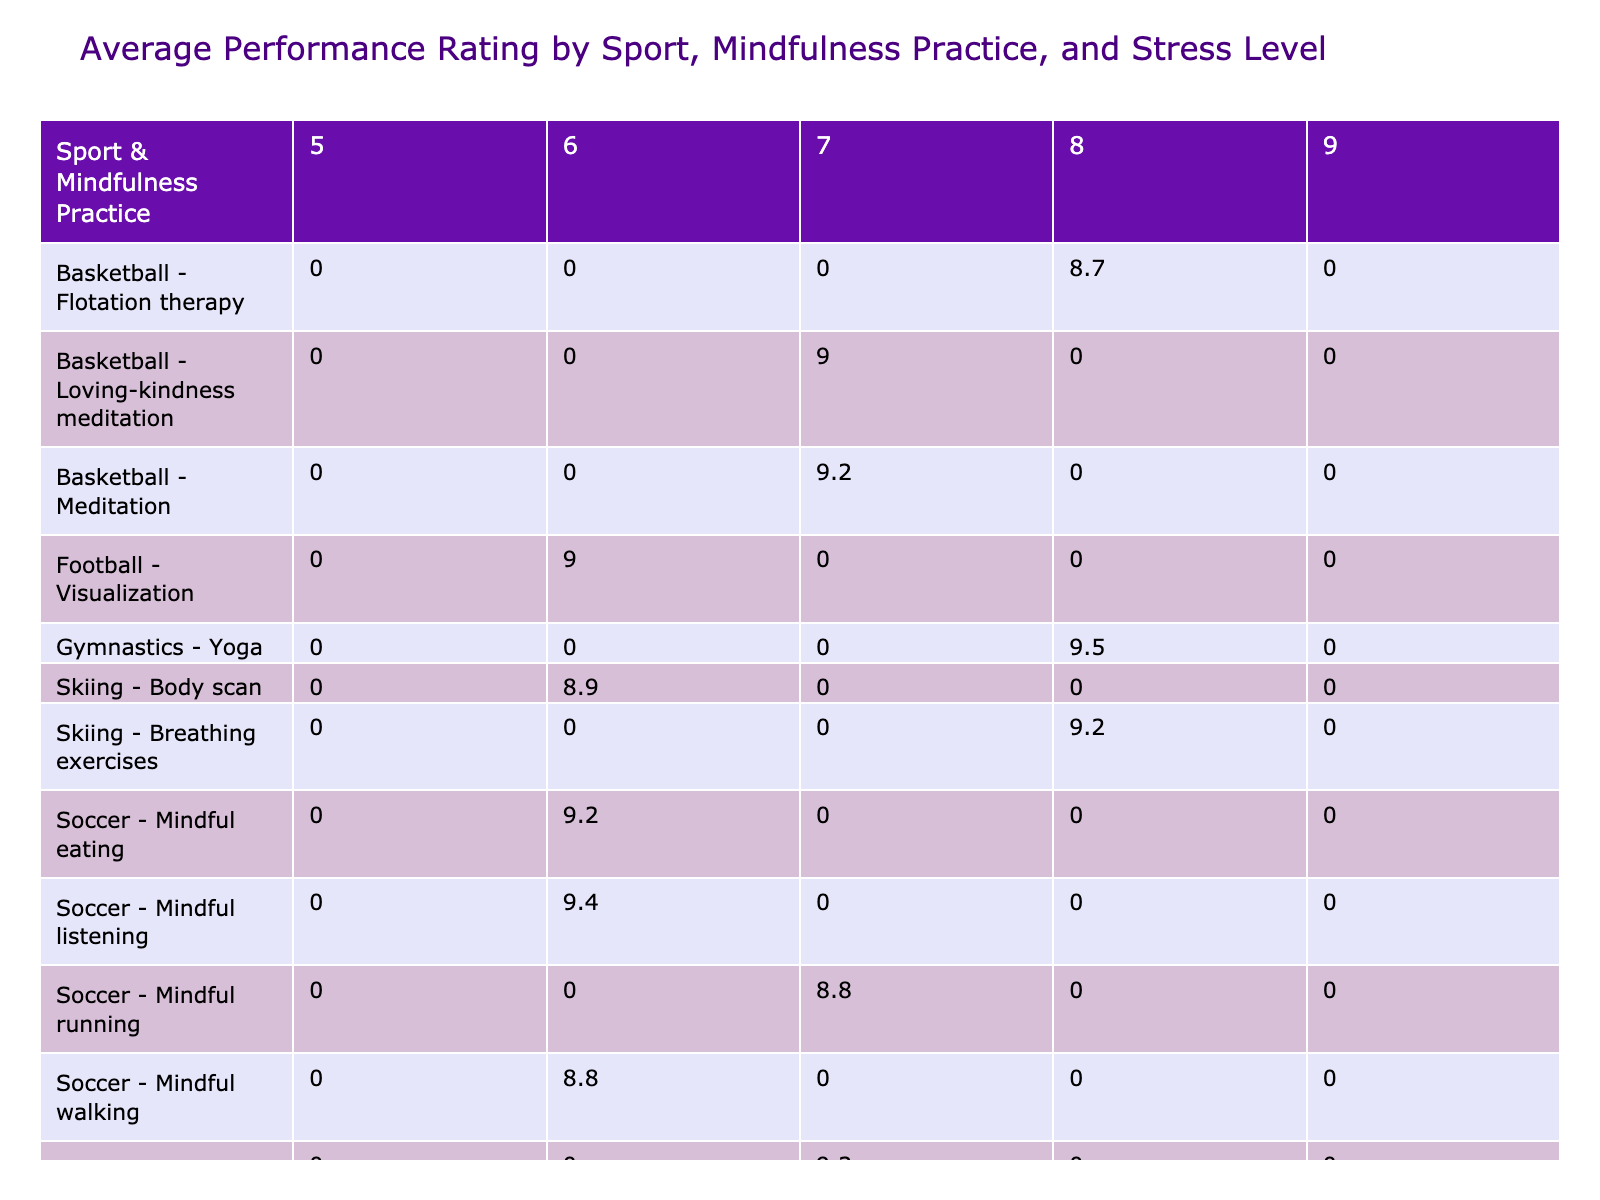What is the highest average performance rating for athletes practicing meditation? From the table, we look for the row labeled “Basketball - Meditation” as this is the only mindfulness practice that mentions meditation. The performance rating under stress level 6 is 9.0 and under stress level 7 is 9.2. The highest among these is 9.2.
Answer: 9.2 Which sport has the lowest average performance rating among athletes practicing yoga? We check the rows with “Tennis - Yoga” and calculate the average ratings across the stress levels (7 for stress level 7 and 8 for stress level 8). The performance ratings are 9.3 and 9.5, respectively. The average is (9.3 + 9.5) / 2 = 9.4. Therefore, the lowest rating in this case is 9.4 for yoga practitioners.
Answer: 9.4 Is there any sport with a performance rating of 8.8 among athletes practicing mindful walking? By examining the row labeled “Soccer - Mindful walking,” we find the performance rating under the stress level of 6 is 8.8. Thus, the answer is yes, soccer has a performance rating of 8.8 with that mindfulness practice.
Answer: Yes What is the average performance rating for athletes who engage in daily mindfulness practices? We look for all rows marked with “Daily” across the mindfulness practice column. Calculating the average performance ratings for these entries (9.2 for basketball meditation, 9.0 for football visualization, 9.4 for swimming progressive relaxation, 8.9 for tennis journaling, 8.8 for swimming mindful stretching, 9.2 for skiing breathing exercises) gives us a total of 54.5 from 6 entries, resulting in an average of 54.5 / 6 = 9.08.
Answer: 9.08 Among the athletes practicing body scan, what is the average performance rating? We focus on the rows labeled “Track - Body scan” and “Skiing - Body scan.” The performance ratings are 9.1 for track and 8.9 for skiing. Adding these gives a total of 9.1 + 8.9 = 18.0; there are 2 entries, averaging 18.0 / 2 = 9.0.
Answer: 9.0 